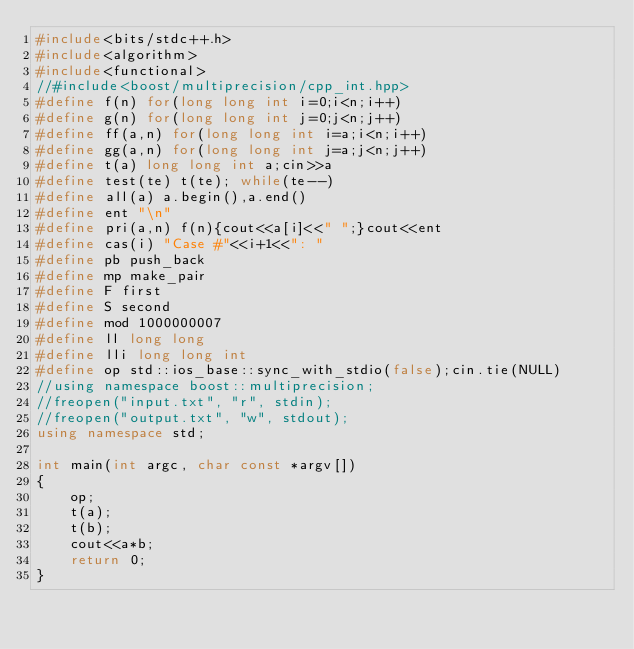<code> <loc_0><loc_0><loc_500><loc_500><_C++_>#include<bits/stdc++.h>
#include<algorithm>
#include<functional>
//#include<boost/multiprecision/cpp_int.hpp>
#define f(n) for(long long int i=0;i<n;i++)
#define g(n) for(long long int j=0;j<n;j++)
#define ff(a,n) for(long long int i=a;i<n;i++)
#define gg(a,n) for(long long int j=a;j<n;j++)
#define t(a) long long int a;cin>>a
#define test(te) t(te); while(te--)
#define all(a) a.begin(),a.end()
#define ent "\n"
#define pri(a,n) f(n){cout<<a[i]<<" ";}cout<<ent
#define cas(i) "Case #"<<i+1<<": "
#define pb push_back
#define mp make_pair
#define F first
#define S second
#define mod 1000000007  
#define ll long long 
#define lli long long int
#define op std::ios_base::sync_with_stdio(false);cin.tie(NULL)
//using namespace boost::multiprecision;
//freopen("input.txt", "r", stdin);
//freopen("output.txt", "w", stdout);
using namespace std;

int main(int argc, char const *argv[])
{
    op;
    t(a);
    t(b);
    cout<<a*b;
    return 0;
}</code> 